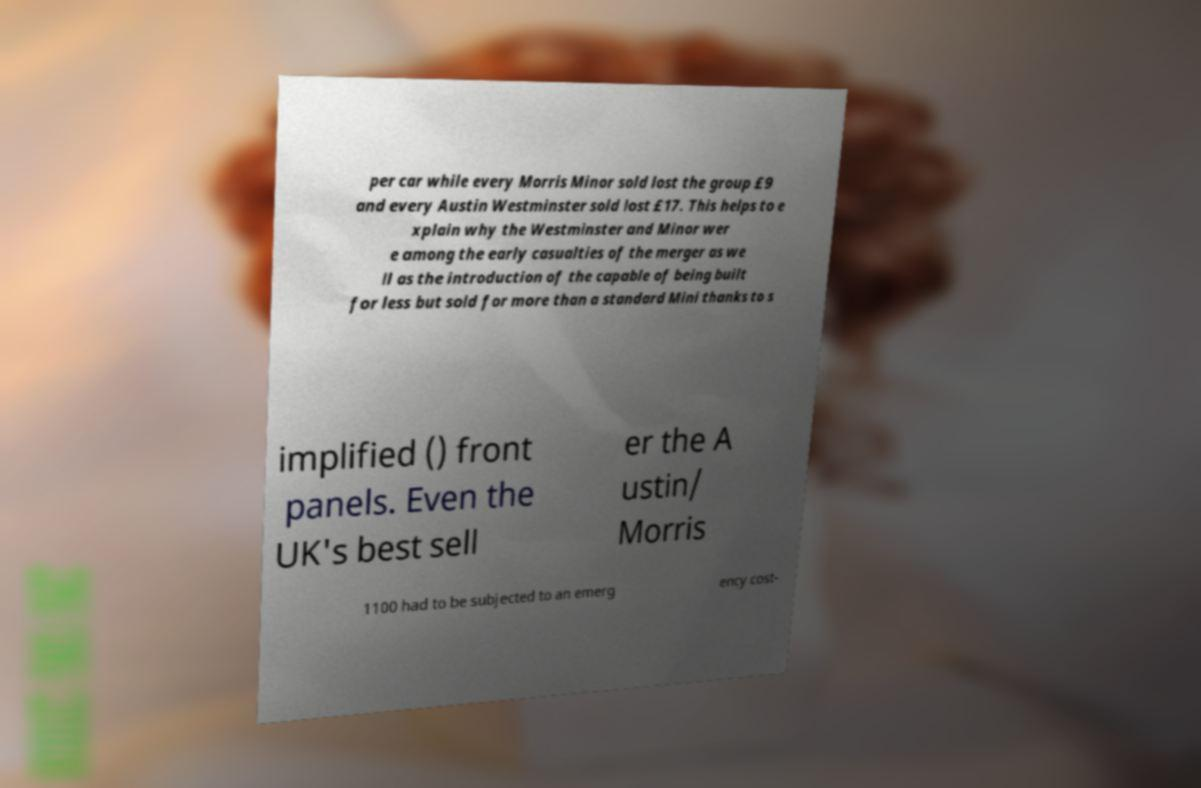Could you assist in decoding the text presented in this image and type it out clearly? per car while every Morris Minor sold lost the group £9 and every Austin Westminster sold lost £17. This helps to e xplain why the Westminster and Minor wer e among the early casualties of the merger as we ll as the introduction of the capable of being built for less but sold for more than a standard Mini thanks to s implified () front panels. Even the UK's best sell er the A ustin/ Morris 1100 had to be subjected to an emerg ency cost- 